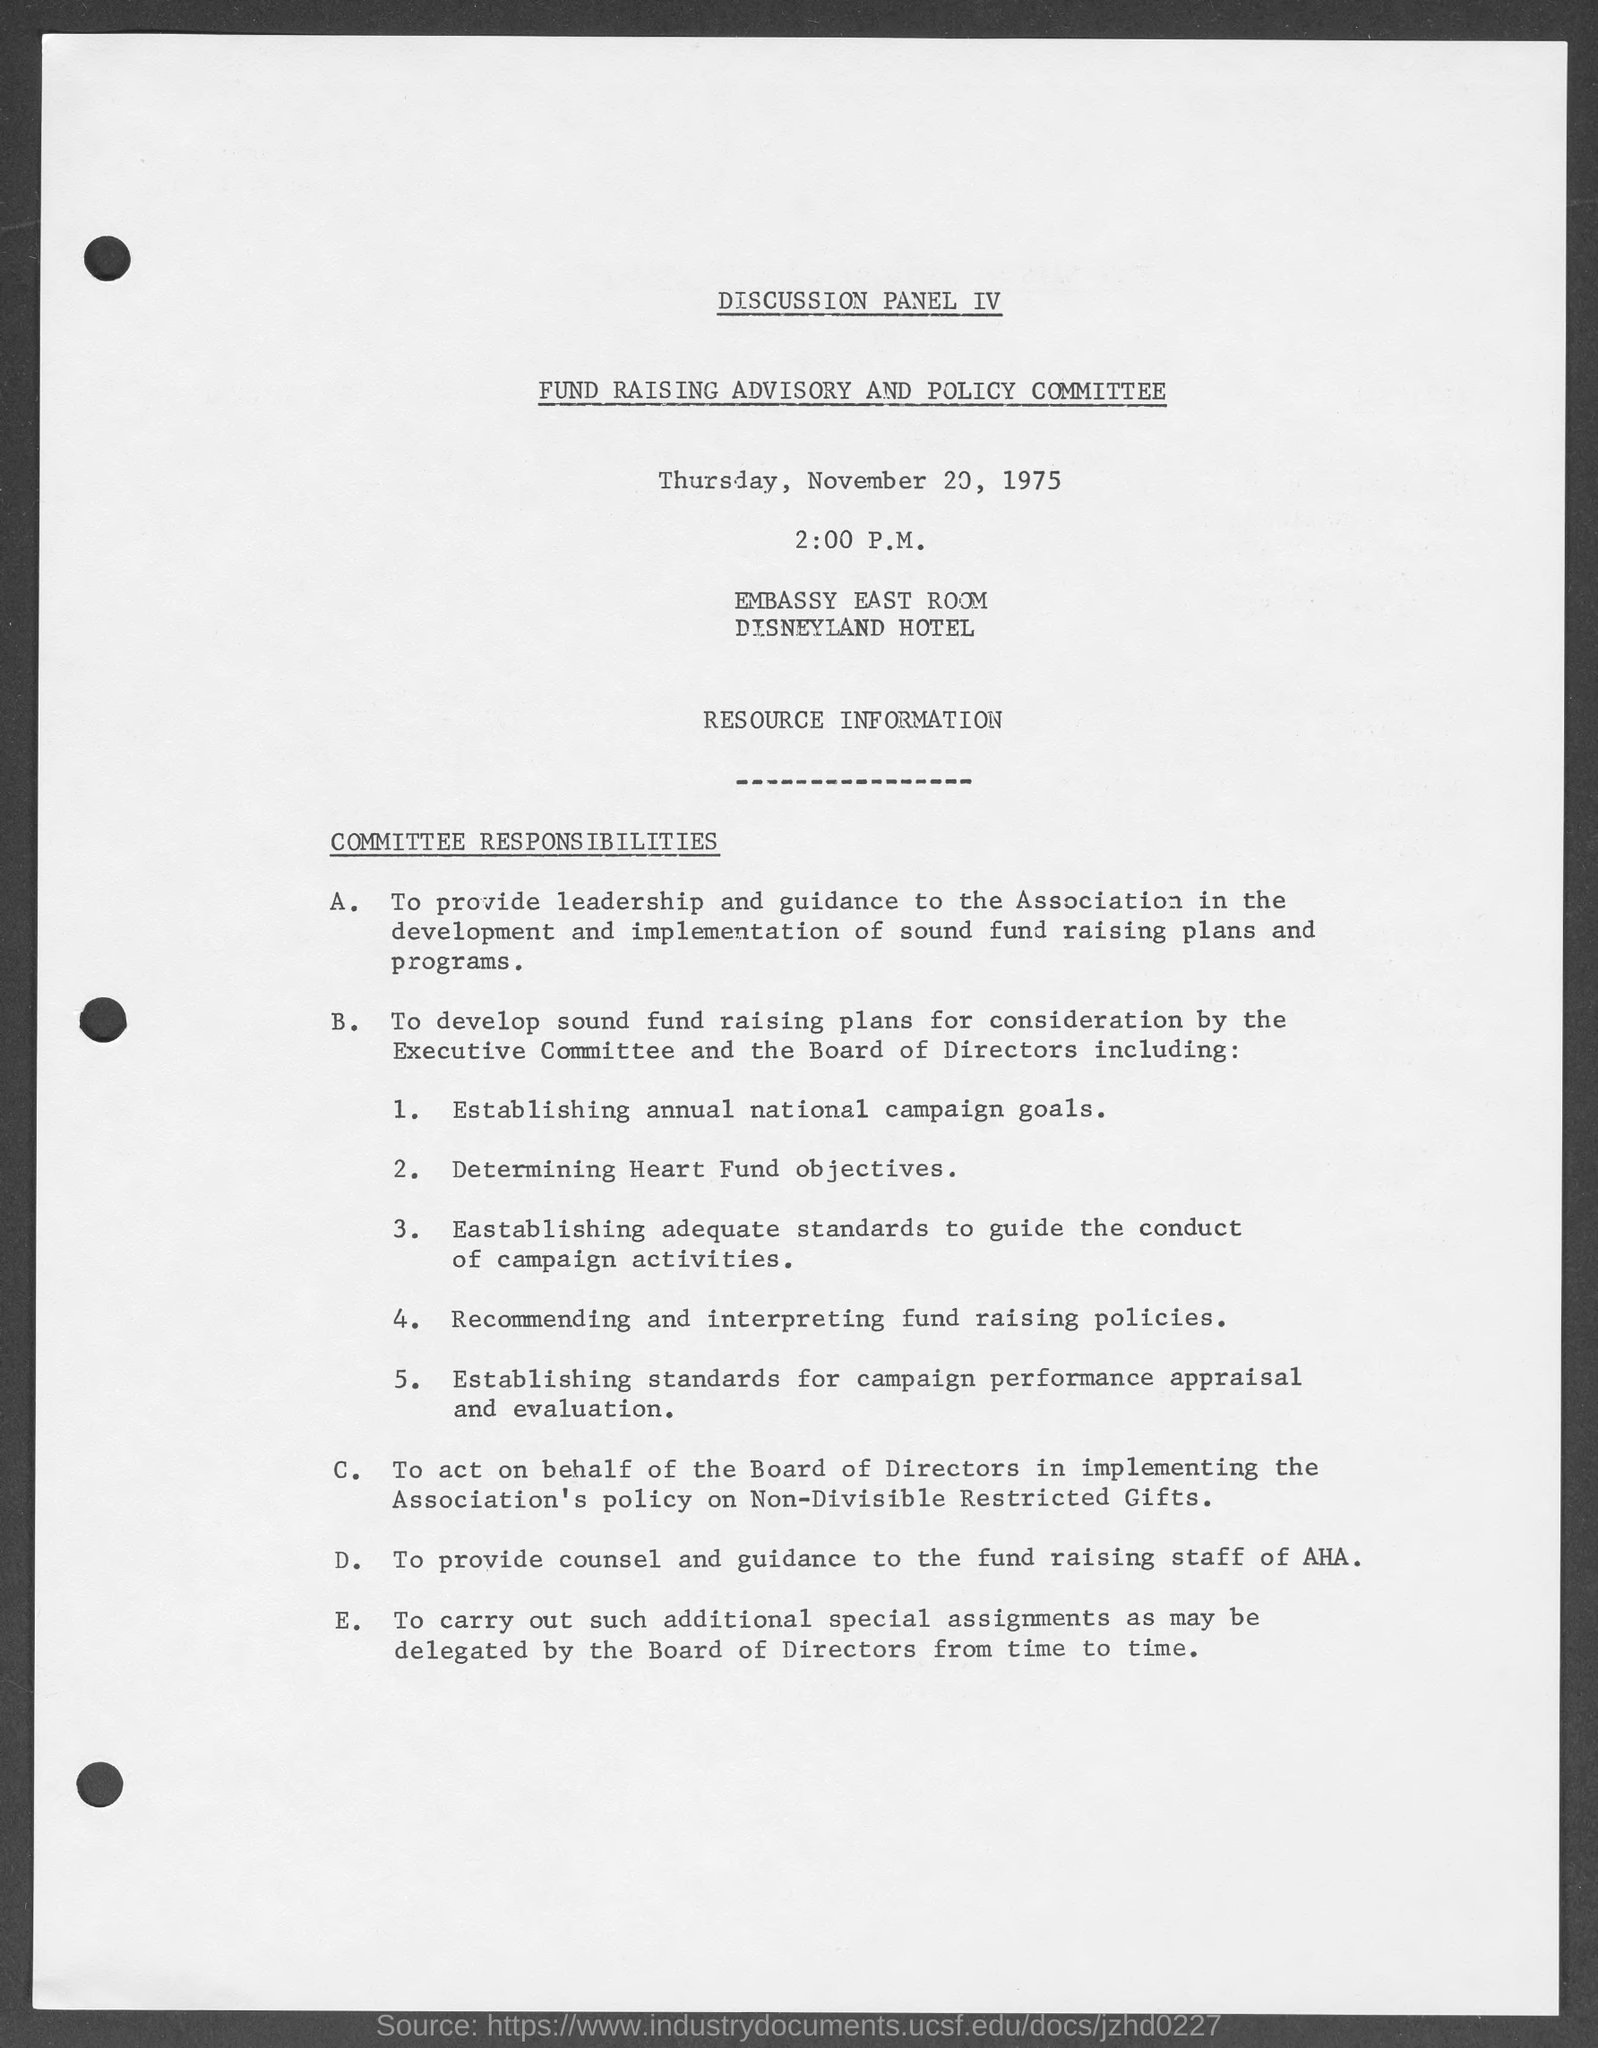Outline some significant characteristics in this image. The document mentions that the date is November 20, 1975. Thursday is mentioned in the page. The meeting took place at 2:00 P.M. The document on the top of the page is titled "Discussion Panel IV" and provides a detailed analysis of the various panel discussions held during the conference. 